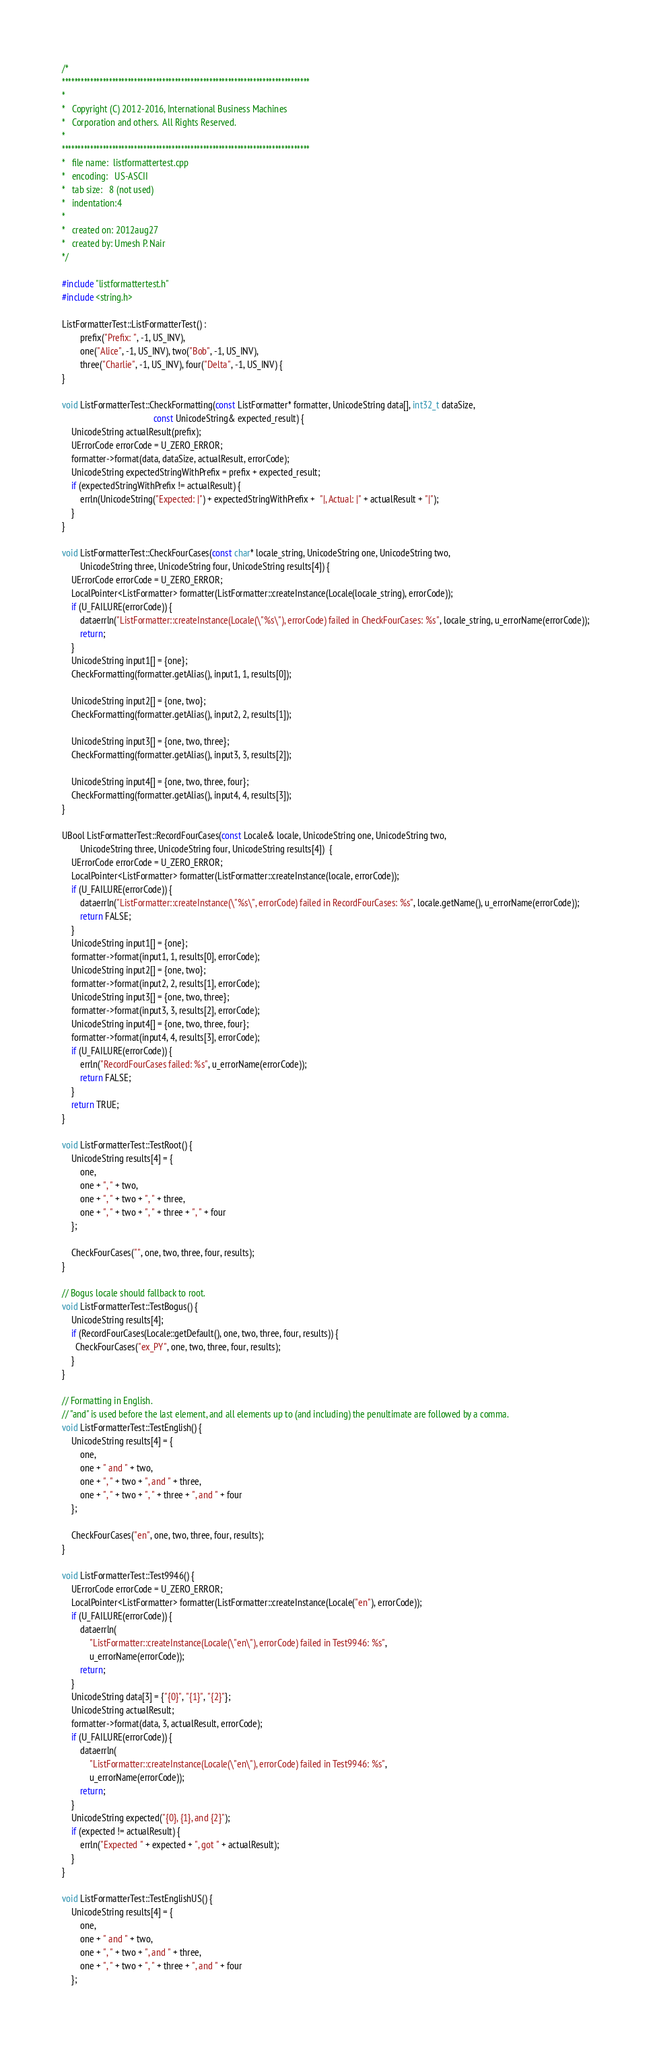<code> <loc_0><loc_0><loc_500><loc_500><_C++_>/*
*******************************************************************************
*
*   Copyright (C) 2012-2016, International Business Machines
*   Corporation and others.  All Rights Reserved.
*
*******************************************************************************
*   file name:  listformattertest.cpp
*   encoding:   US-ASCII
*   tab size:   8 (not used)
*   indentation:4
*
*   created on: 2012aug27
*   created by: Umesh P. Nair
*/

#include "listformattertest.h"
#include <string.h>

ListFormatterTest::ListFormatterTest() :
        prefix("Prefix: ", -1, US_INV),
        one("Alice", -1, US_INV), two("Bob", -1, US_INV),
        three("Charlie", -1, US_INV), four("Delta", -1, US_INV) {
}

void ListFormatterTest::CheckFormatting(const ListFormatter* formatter, UnicodeString data[], int32_t dataSize,
                                        const UnicodeString& expected_result) {
    UnicodeString actualResult(prefix);
    UErrorCode errorCode = U_ZERO_ERROR;
    formatter->format(data, dataSize, actualResult, errorCode);
    UnicodeString expectedStringWithPrefix = prefix + expected_result;
    if (expectedStringWithPrefix != actualResult) {
        errln(UnicodeString("Expected: |") + expectedStringWithPrefix +  "|, Actual: |" + actualResult + "|");
    }
}

void ListFormatterTest::CheckFourCases(const char* locale_string, UnicodeString one, UnicodeString two,
        UnicodeString three, UnicodeString four, UnicodeString results[4]) {
    UErrorCode errorCode = U_ZERO_ERROR;
    LocalPointer<ListFormatter> formatter(ListFormatter::createInstance(Locale(locale_string), errorCode));
    if (U_FAILURE(errorCode)) {
        dataerrln("ListFormatter::createInstance(Locale(\"%s\"), errorCode) failed in CheckFourCases: %s", locale_string, u_errorName(errorCode));
        return;
    }
    UnicodeString input1[] = {one};
    CheckFormatting(formatter.getAlias(), input1, 1, results[0]);

    UnicodeString input2[] = {one, two};
    CheckFormatting(formatter.getAlias(), input2, 2, results[1]);

    UnicodeString input3[] = {one, two, three};
    CheckFormatting(formatter.getAlias(), input3, 3, results[2]);

    UnicodeString input4[] = {one, two, three, four};
    CheckFormatting(formatter.getAlias(), input4, 4, results[3]);
}

UBool ListFormatterTest::RecordFourCases(const Locale& locale, UnicodeString one, UnicodeString two,
        UnicodeString three, UnicodeString four, UnicodeString results[4])  {
    UErrorCode errorCode = U_ZERO_ERROR;
    LocalPointer<ListFormatter> formatter(ListFormatter::createInstance(locale, errorCode));
    if (U_FAILURE(errorCode)) {
        dataerrln("ListFormatter::createInstance(\"%s\", errorCode) failed in RecordFourCases: %s", locale.getName(), u_errorName(errorCode));
        return FALSE;
    }
    UnicodeString input1[] = {one};
    formatter->format(input1, 1, results[0], errorCode);
    UnicodeString input2[] = {one, two};
    formatter->format(input2, 2, results[1], errorCode);
    UnicodeString input3[] = {one, two, three};
    formatter->format(input3, 3, results[2], errorCode);
    UnicodeString input4[] = {one, two, three, four};
    formatter->format(input4, 4, results[3], errorCode);
    if (U_FAILURE(errorCode)) {
        errln("RecordFourCases failed: %s", u_errorName(errorCode));
        return FALSE;
    }
    return TRUE;
}

void ListFormatterTest::TestRoot() {
    UnicodeString results[4] = {
        one,
        one + ", " + two,
        one + ", " + two + ", " + three,
        one + ", " + two + ", " + three + ", " + four
    };

    CheckFourCases("", one, two, three, four, results);
}

// Bogus locale should fallback to root.
void ListFormatterTest::TestBogus() {
    UnicodeString results[4];
    if (RecordFourCases(Locale::getDefault(), one, two, three, four, results)) {
      CheckFourCases("ex_PY", one, two, three, four, results);
    }
}

// Formatting in English.
// "and" is used before the last element, and all elements up to (and including) the penultimate are followed by a comma.
void ListFormatterTest::TestEnglish() {
    UnicodeString results[4] = {
        one,
        one + " and " + two,
        one + ", " + two + ", and " + three,
        one + ", " + two + ", " + three + ", and " + four
    };

    CheckFourCases("en", one, two, three, four, results);
}

void ListFormatterTest::Test9946() {
    UErrorCode errorCode = U_ZERO_ERROR;
    LocalPointer<ListFormatter> formatter(ListFormatter::createInstance(Locale("en"), errorCode));
    if (U_FAILURE(errorCode)) {
        dataerrln(
            "ListFormatter::createInstance(Locale(\"en\"), errorCode) failed in Test9946: %s",
            u_errorName(errorCode));
        return;
    }
    UnicodeString data[3] = {"{0}", "{1}", "{2}"};
    UnicodeString actualResult;
    formatter->format(data, 3, actualResult, errorCode);
    if (U_FAILURE(errorCode)) {
        dataerrln(
            "ListFormatter::createInstance(Locale(\"en\"), errorCode) failed in Test9946: %s",
            u_errorName(errorCode));
        return;
    }
    UnicodeString expected("{0}, {1}, and {2}");
    if (expected != actualResult) {
        errln("Expected " + expected + ", got " + actualResult);
    }
}

void ListFormatterTest::TestEnglishUS() {
    UnicodeString results[4] = {
        one,
        one + " and " + two,
        one + ", " + two + ", and " + three,
        one + ", " + two + ", " + three + ", and " + four
    };
</code> 